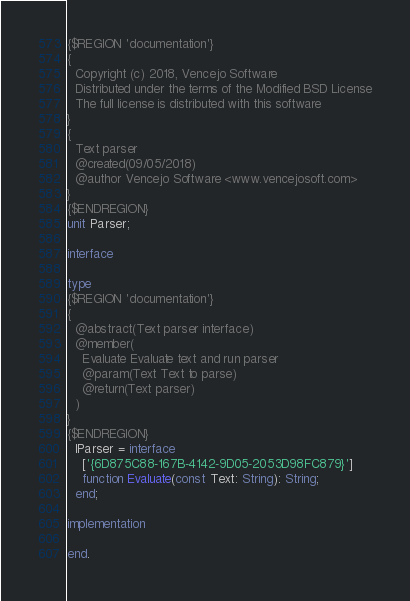<code> <loc_0><loc_0><loc_500><loc_500><_Pascal_>{$REGION 'documentation'}
{
  Copyright (c) 2018, Vencejo Software
  Distributed under the terms of the Modified BSD License
  The full license is distributed with this software
}
{
  Text parser
  @created(09/05/2018)
  @author Vencejo Software <www.vencejosoft.com>
}
{$ENDREGION}
unit Parser;

interface

type
{$REGION 'documentation'}
{
  @abstract(Text parser interface)
  @member(
    Evaluate Evaluate text and run parser
    @param(Text Text to parse)
    @return(Text parser)
  )
}
{$ENDREGION}
  IParser = interface
    ['{6D875C88-167B-4142-9D05-2053D98FC879}']
    function Evaluate(const Text: String): String;
  end;

implementation

end.
</code> 